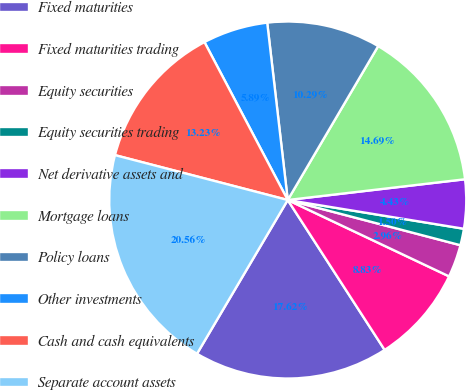Convert chart. <chart><loc_0><loc_0><loc_500><loc_500><pie_chart><fcel>Fixed maturities<fcel>Fixed maturities trading<fcel>Equity securities<fcel>Equity securities trading<fcel>Net derivative assets and<fcel>Mortgage loans<fcel>Policy loans<fcel>Other investments<fcel>Cash and cash equivalents<fcel>Separate account assets<nl><fcel>17.62%<fcel>8.83%<fcel>2.96%<fcel>1.5%<fcel>4.43%<fcel>14.69%<fcel>10.29%<fcel>5.89%<fcel>13.23%<fcel>20.56%<nl></chart> 